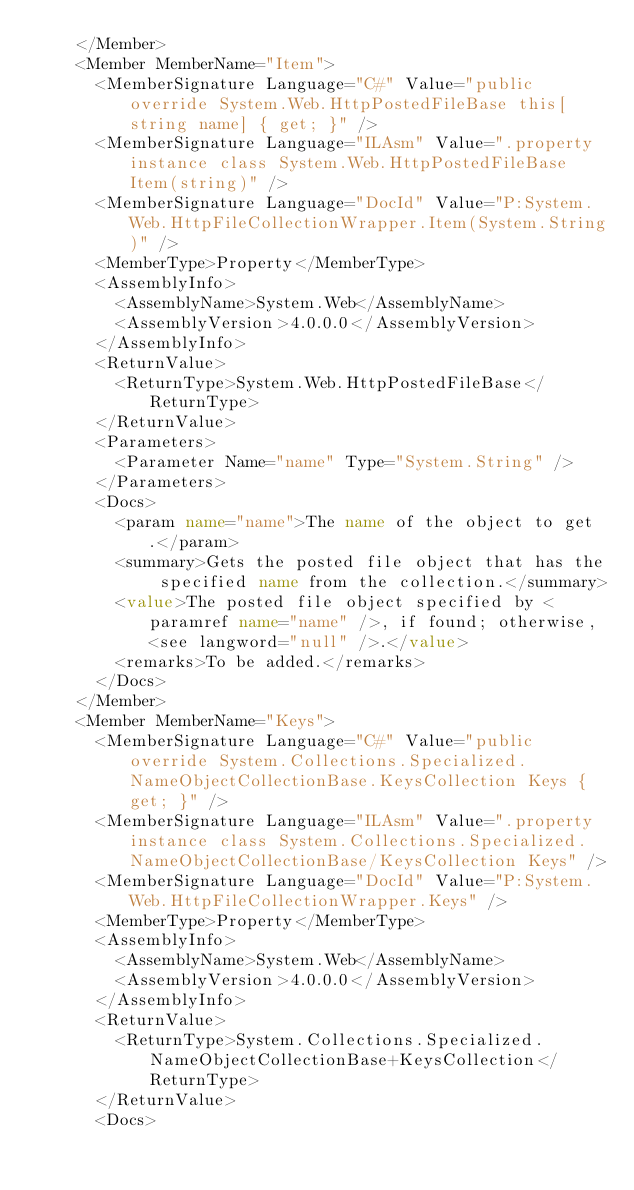Convert code to text. <code><loc_0><loc_0><loc_500><loc_500><_XML_>    </Member>
    <Member MemberName="Item">
      <MemberSignature Language="C#" Value="public override System.Web.HttpPostedFileBase this[string name] { get; }" />
      <MemberSignature Language="ILAsm" Value=".property instance class System.Web.HttpPostedFileBase Item(string)" />
      <MemberSignature Language="DocId" Value="P:System.Web.HttpFileCollectionWrapper.Item(System.String)" />
      <MemberType>Property</MemberType>
      <AssemblyInfo>
        <AssemblyName>System.Web</AssemblyName>
        <AssemblyVersion>4.0.0.0</AssemblyVersion>
      </AssemblyInfo>
      <ReturnValue>
        <ReturnType>System.Web.HttpPostedFileBase</ReturnType>
      </ReturnValue>
      <Parameters>
        <Parameter Name="name" Type="System.String" />
      </Parameters>
      <Docs>
        <param name="name">The name of the object to get.</param>
        <summary>Gets the posted file object that has the specified name from the collection.</summary>
        <value>The posted file object specified by <paramref name="name" />, if found; otherwise, <see langword="null" />.</value>
        <remarks>To be added.</remarks>
      </Docs>
    </Member>
    <Member MemberName="Keys">
      <MemberSignature Language="C#" Value="public override System.Collections.Specialized.NameObjectCollectionBase.KeysCollection Keys { get; }" />
      <MemberSignature Language="ILAsm" Value=".property instance class System.Collections.Specialized.NameObjectCollectionBase/KeysCollection Keys" />
      <MemberSignature Language="DocId" Value="P:System.Web.HttpFileCollectionWrapper.Keys" />
      <MemberType>Property</MemberType>
      <AssemblyInfo>
        <AssemblyName>System.Web</AssemblyName>
        <AssemblyVersion>4.0.0.0</AssemblyVersion>
      </AssemblyInfo>
      <ReturnValue>
        <ReturnType>System.Collections.Specialized.NameObjectCollectionBase+KeysCollection</ReturnType>
      </ReturnValue>
      <Docs></code> 